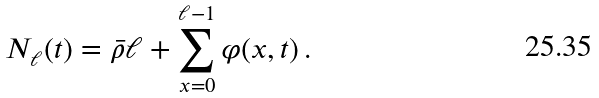<formula> <loc_0><loc_0><loc_500><loc_500>N _ { \ell } ( t ) = \bar { \rho } \ell + \sum _ { x = 0 } ^ { \ell - 1 } \varphi ( x , t ) \, .</formula> 